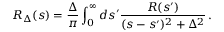Convert formula to latex. <formula><loc_0><loc_0><loc_500><loc_500>R _ { \Delta } ( s ) = \frac { \Delta } { \pi } \int _ { 0 } ^ { \infty } d s ^ { \prime } \frac { R ( s ^ { \prime } ) } { ( s - s ^ { \prime } ) ^ { 2 } + \Delta ^ { 2 } } \, .</formula> 